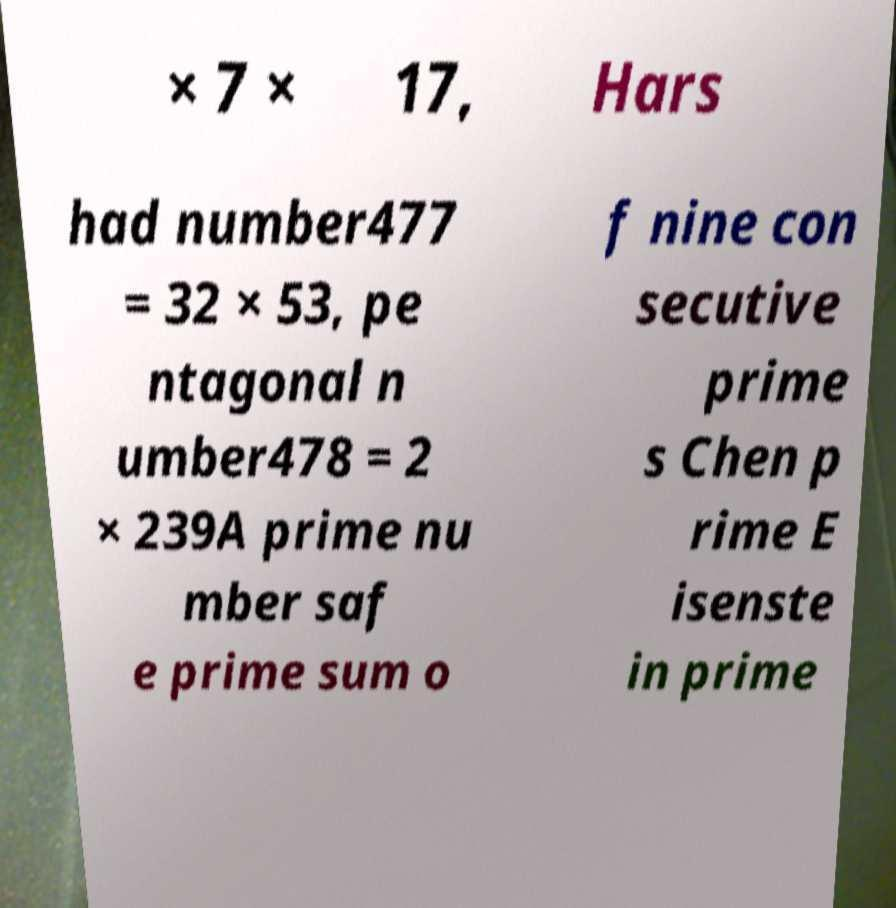Can you read and provide the text displayed in the image?This photo seems to have some interesting text. Can you extract and type it out for me? × 7 × 17, Hars had number477 = 32 × 53, pe ntagonal n umber478 = 2 × 239A prime nu mber saf e prime sum o f nine con secutive prime s Chen p rime E isenste in prime 